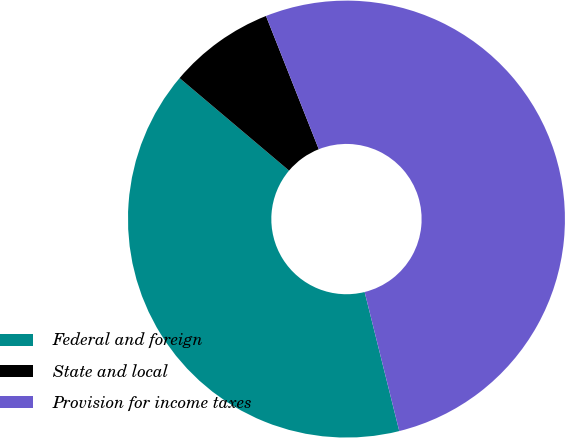Convert chart to OTSL. <chart><loc_0><loc_0><loc_500><loc_500><pie_chart><fcel>Federal and foreign<fcel>State and local<fcel>Provision for income taxes<nl><fcel>40.05%<fcel>7.83%<fcel>52.12%<nl></chart> 